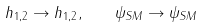Convert formula to latex. <formula><loc_0><loc_0><loc_500><loc_500>h _ { 1 , 2 } \to h _ { 1 , 2 } , \quad \psi _ { S M } \to \psi _ { S M }</formula> 